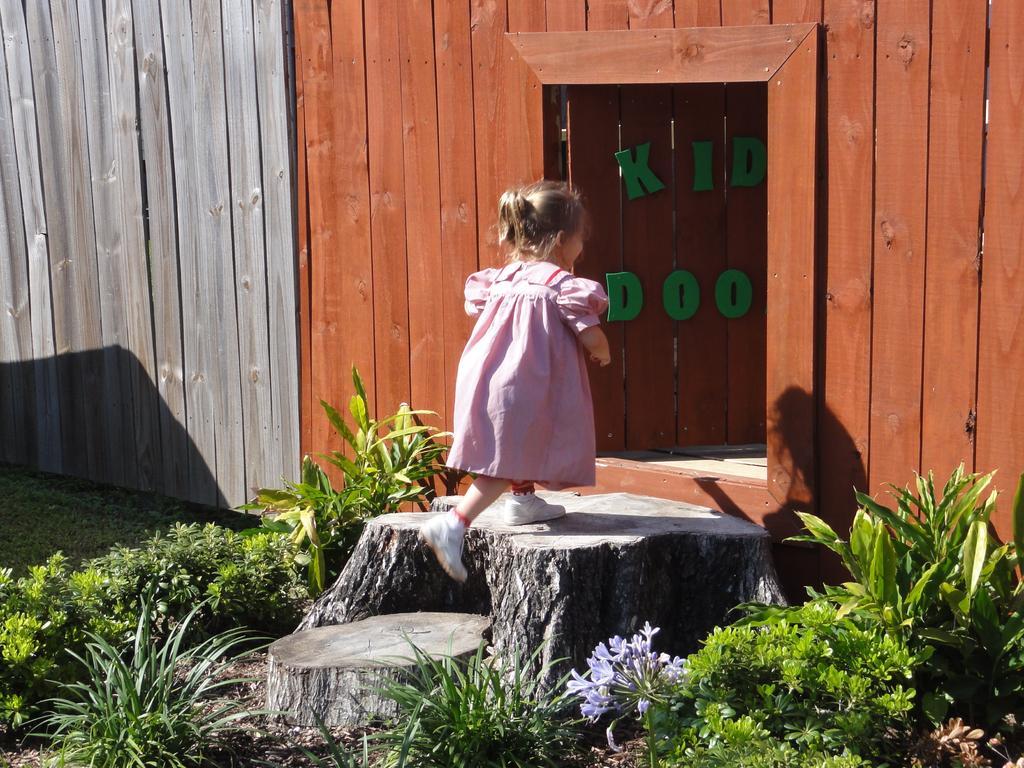Can you describe this image briefly? In this picture I can see a girl walking and I can see plants and couple of wooden barks on the ground and I can see text on the wooden wall. 